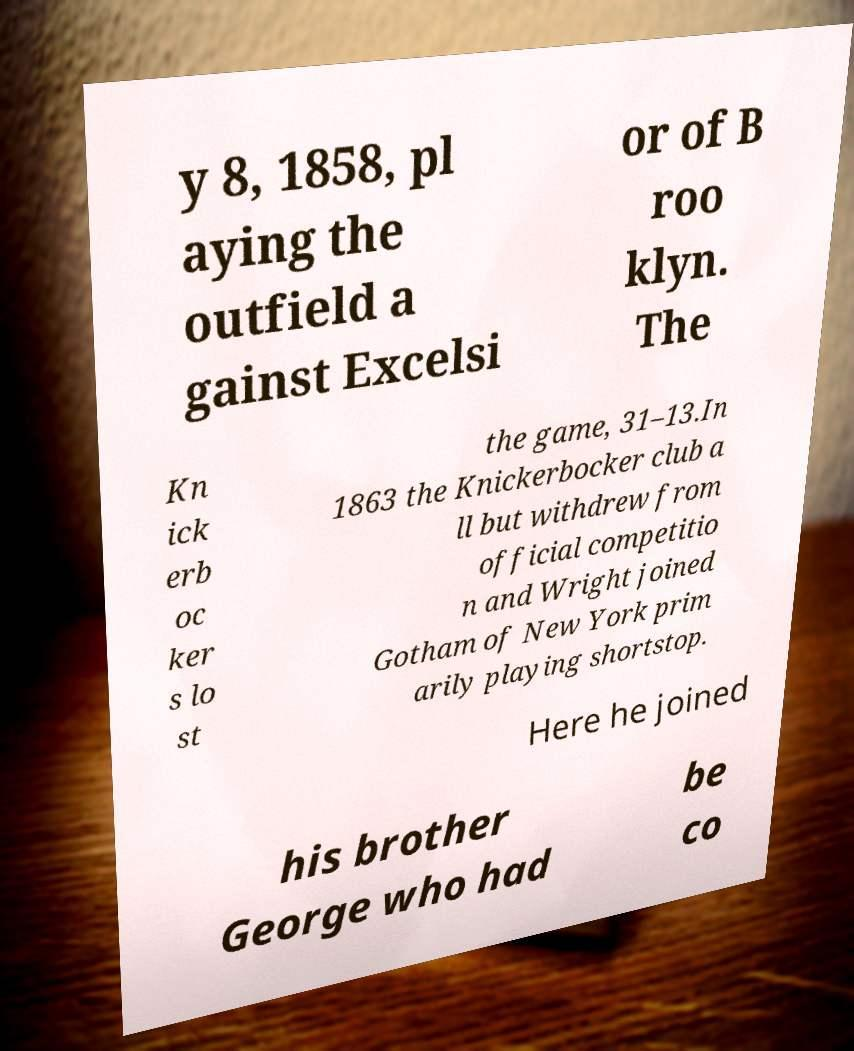For documentation purposes, I need the text within this image transcribed. Could you provide that? y 8, 1858, pl aying the outfield a gainst Excelsi or of B roo klyn. The Kn ick erb oc ker s lo st the game, 31–13.In 1863 the Knickerbocker club a ll but withdrew from official competitio n and Wright joined Gotham of New York prim arily playing shortstop. Here he joined his brother George who had be co 